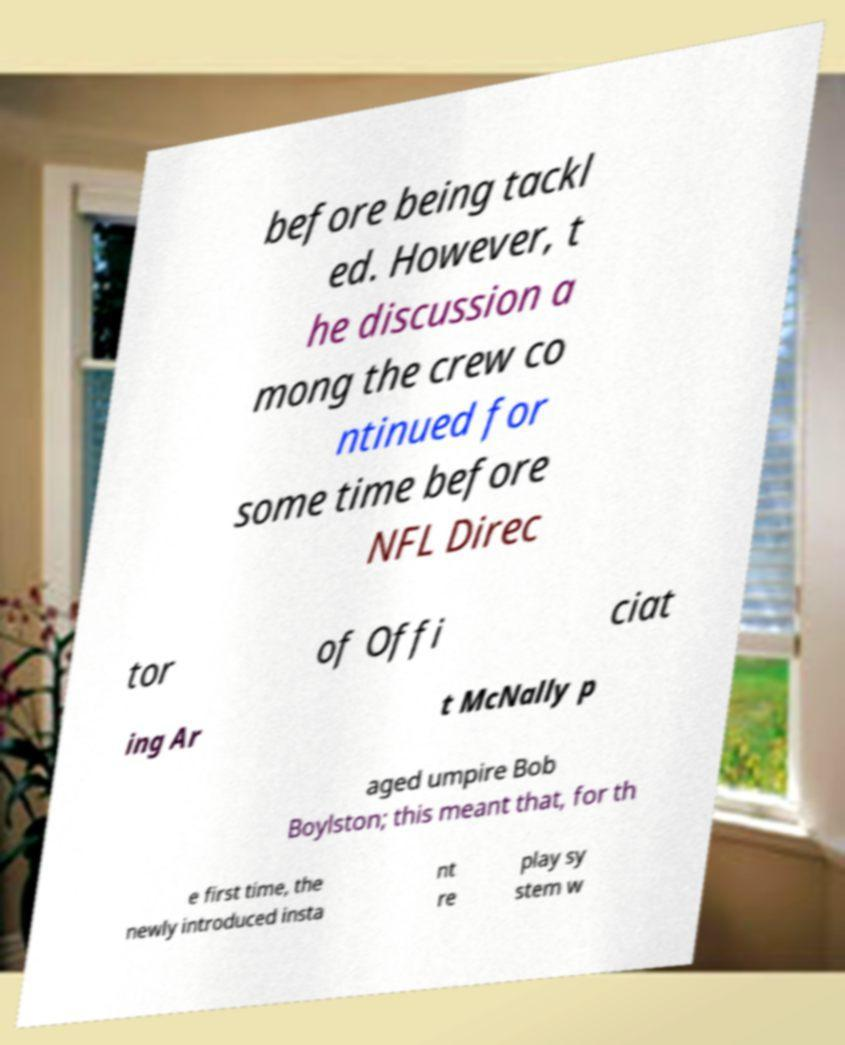Please read and relay the text visible in this image. What does it say? before being tackl ed. However, t he discussion a mong the crew co ntinued for some time before NFL Direc tor of Offi ciat ing Ar t McNally p aged umpire Bob Boylston; this meant that, for th e first time, the newly introduced insta nt re play sy stem w 